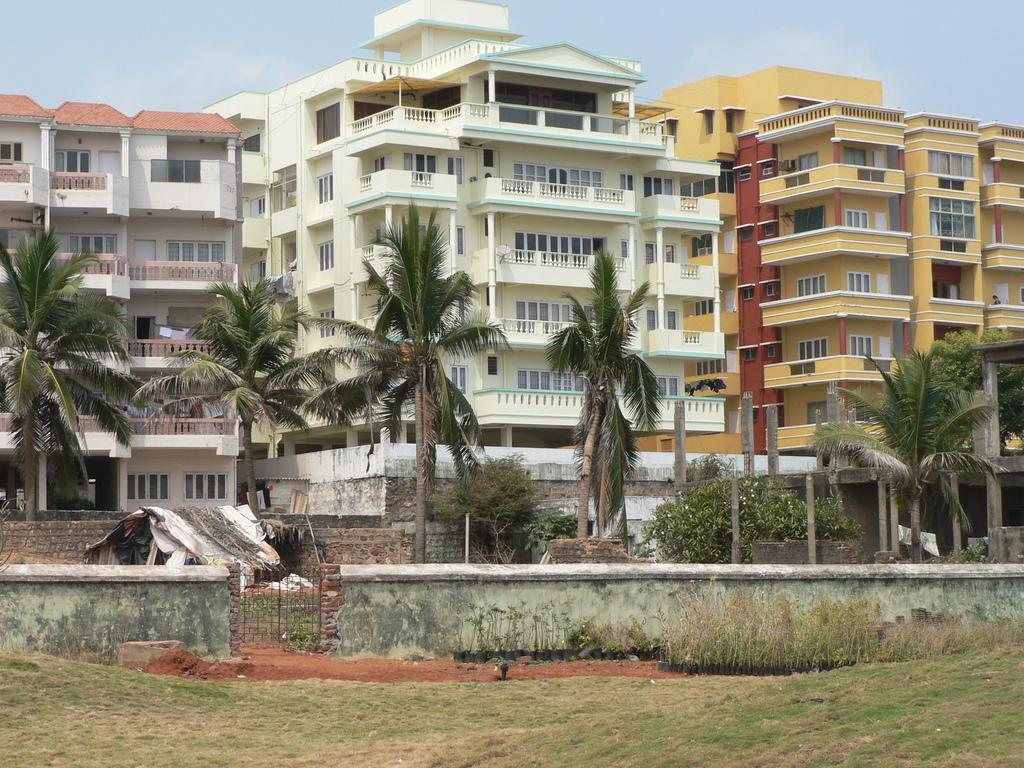What type of structure is present in the image? There is a hut in the image. What can be seen in the image besides the hut? There are green trees and buildings in the background of the image. What is the color of the sky in the image? The sky is visible in the image, and it has a white and blue color. How does the hut contribute to reducing pollution in the image? The image does not provide information about pollution or the hut's impact on it. 